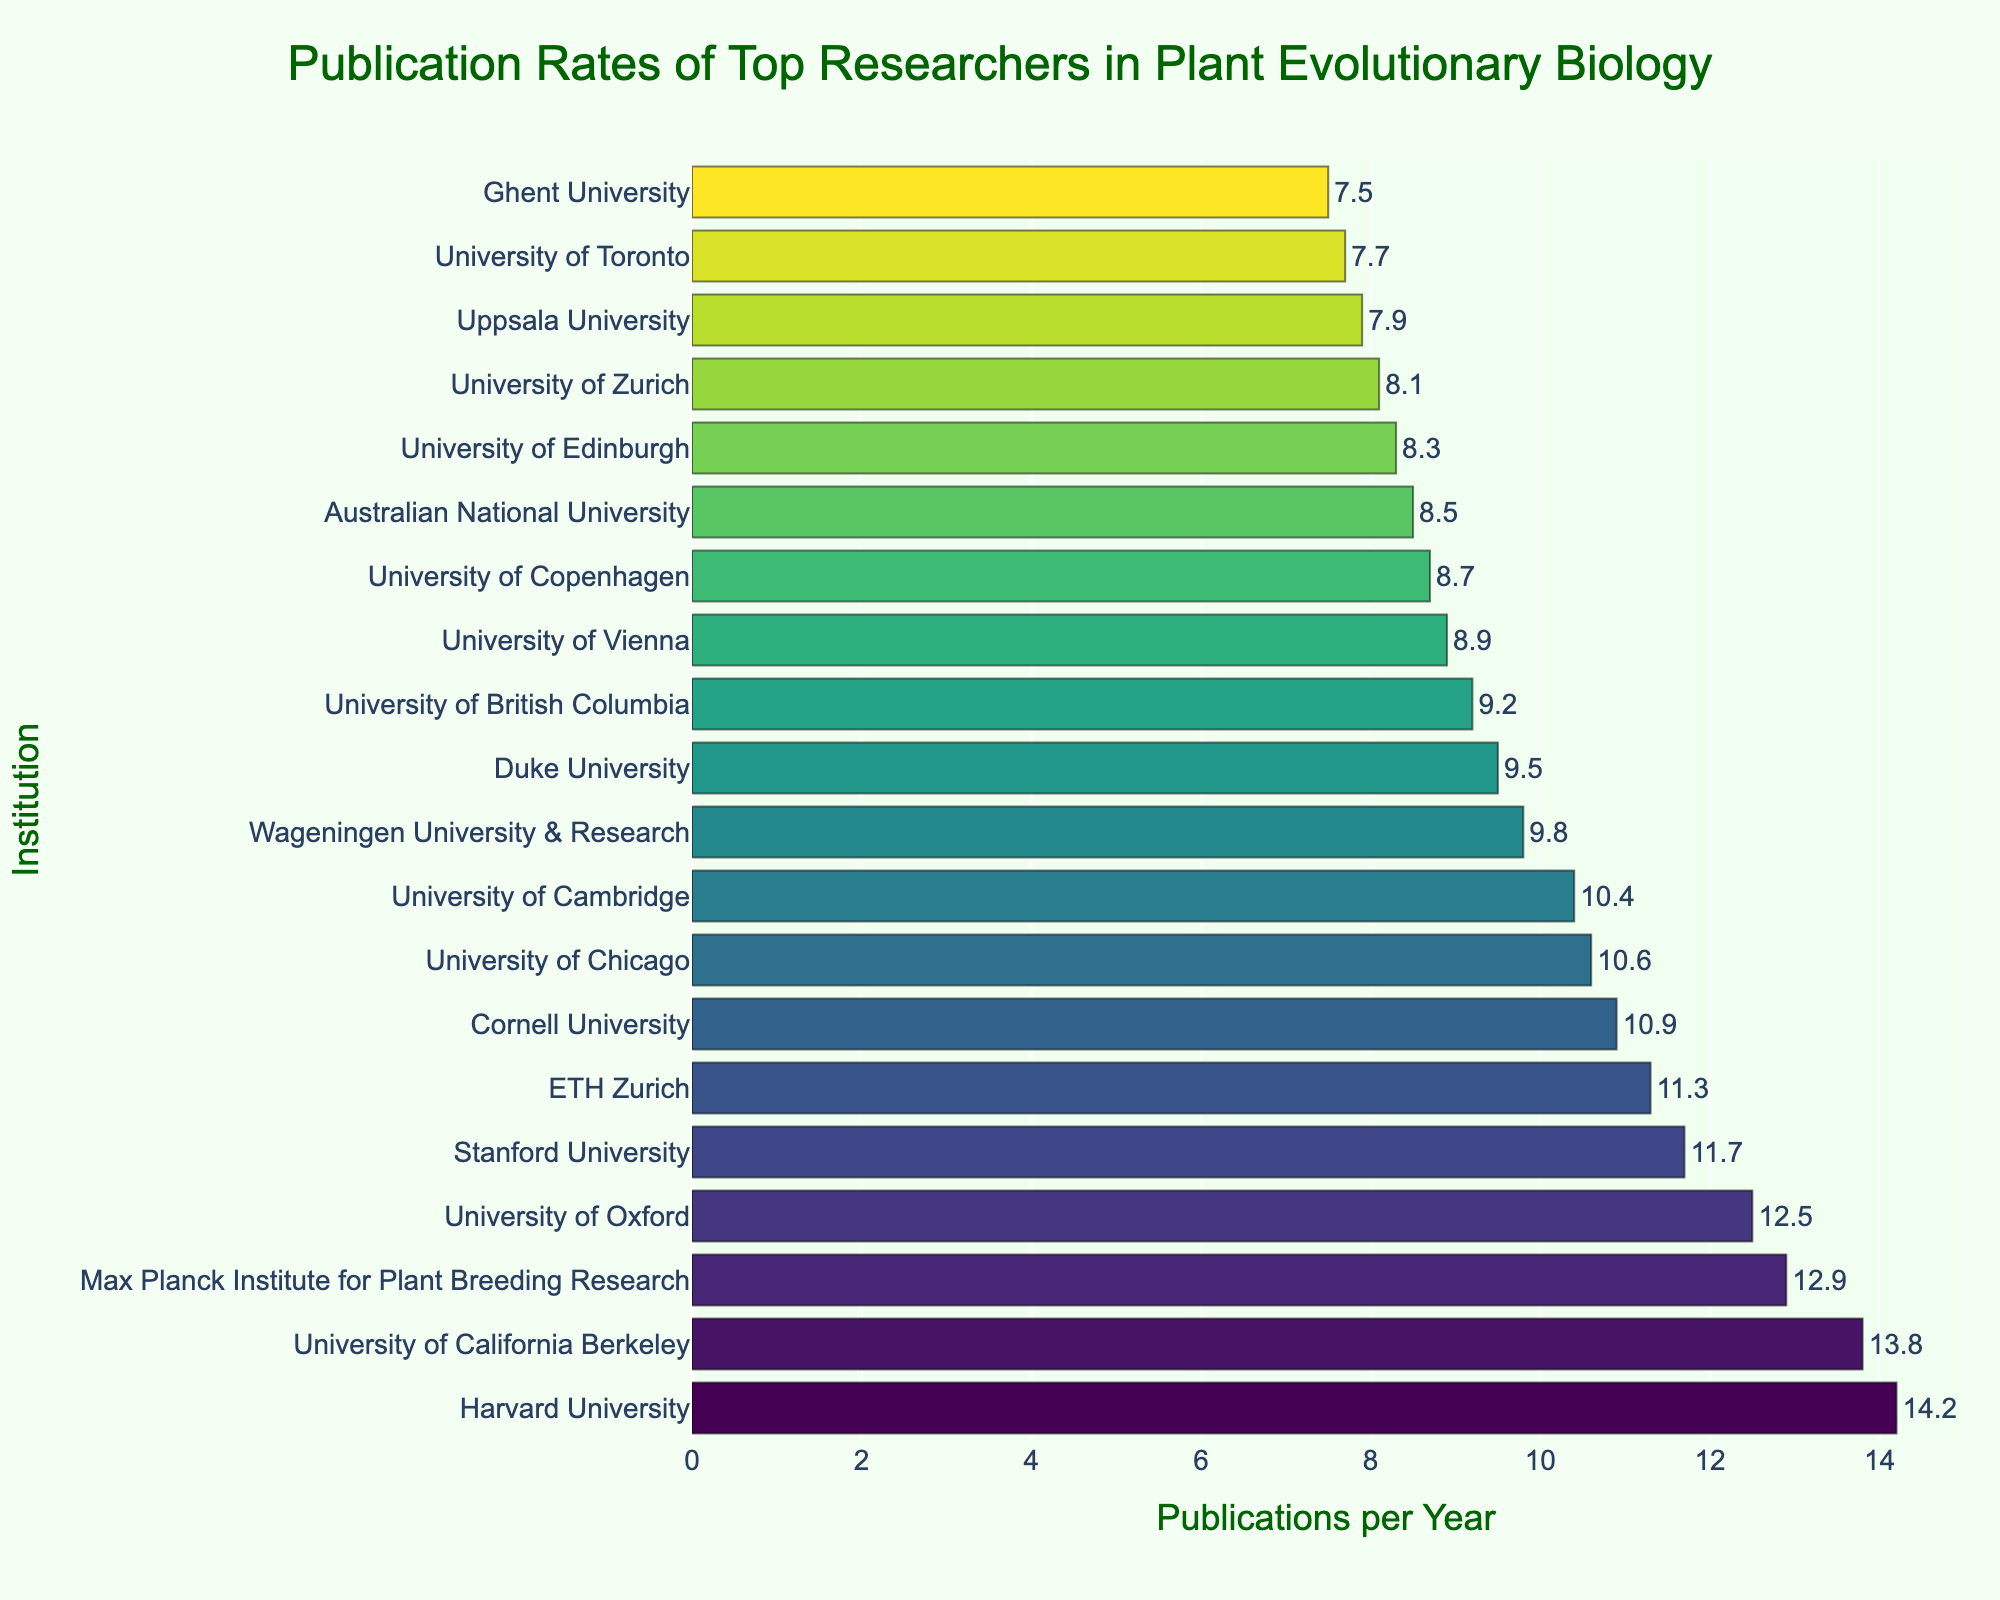Which institution has the highest publication rate? By looking at the top bar in the figure, we see that Harvard University has the highest number of publications per year.
Answer: Harvard University Which institution has the lowest publication rate? By looking at the bottom bar in the figure, we see that Ghent University has the lowest number of publications per year.
Answer: Ghent University What is the difference in publication rates between Harvard University and Ghent University? Harvard University has 14.2 publications per year, while Ghent University has 7.5 publications per year. The difference is 14.2 - 7.5 = 6.7.
Answer: 6.7 How many institutions have a publication rate greater than 10? By counting the institutions with bars extending beyond the 10 publications per year mark, we see there are 9 such institutions.
Answer: 9 What is the average publication rate of the top five institutions? The top five institutions and their publication rates are: Harvard University (14.2), University of California Berkeley (13.8), Max Planck Institute for Plant Breeding Research (12.9), University of Oxford (12.5), and Stanford University (11.7). The sum is 14.2 + 13.8 + 12.9 + 12.5 + 11.7 = 65.1. The average is 65.1 / 5 = 13.02.
Answer: 13.02 Which institution has a publication rate closest to the median of the data? With 20 institutions, the median is the average of the 10th and 11th values when sorted. Those institutions are Wageningen University & Research (9.8) and Duke University (9.5). The median is (9.8 + 9.5) / 2 = 9.65. University of British Columbia (9.2) is the closest to this median.
Answer: University of British Columbia Compare the publication rates of the University of Cambridge and Cornell University. Which one is higher and by how much? The University of Cambridge has 10.4 publications per year and Cornell University has 10.9 publications per year. Cornell University has a higher rate by 10.9 - 10.4 = 0.5.
Answer: Cornell University, 0.5 How many institutions have publication rates between 9 and 11? By examining the bars that fall between 9 and 11 on the x-axis, we count: Wageningen University & Research (9.8), Duke University (9.5), University of British Columbia (9.2), University of Vienna (8.9), University of Cambridge (10.4), University of Chicago (10.6), and Cornell University (10.9). There are 7 institutions in total.
Answer: 7 Which institution appears visually closest in color to the University of Oxford, based on the color scale used? The University of Oxford is assigned a shade within the yellow-green range on the Viridis color scale. The University of Cambridge, which is relatively close in publication rate and position, appears to have a similar color.
Answer: University of Cambridge What is the combined publication rate of the institutions located in Switzerland (ETH Zurich and University of Zurich)? ETH Zurich has a publication rate of 11.3 and University of Zurich has a publication rate of 8.1. The combined rate is 11.3 + 8.1 = 19.4
Answer: 19.4 